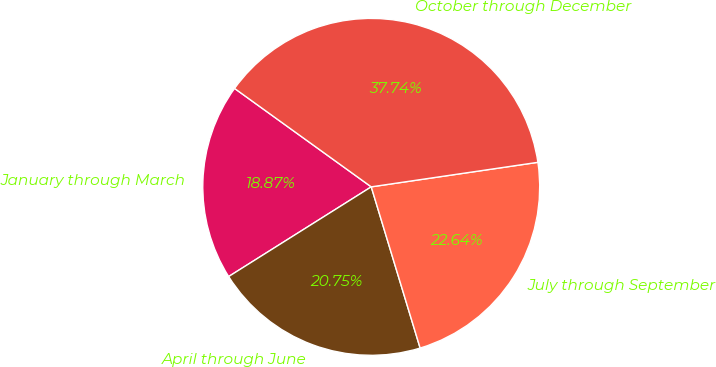Convert chart. <chart><loc_0><loc_0><loc_500><loc_500><pie_chart><fcel>January through March<fcel>April through June<fcel>July through September<fcel>October through December<nl><fcel>18.87%<fcel>20.75%<fcel>22.64%<fcel>37.74%<nl></chart> 